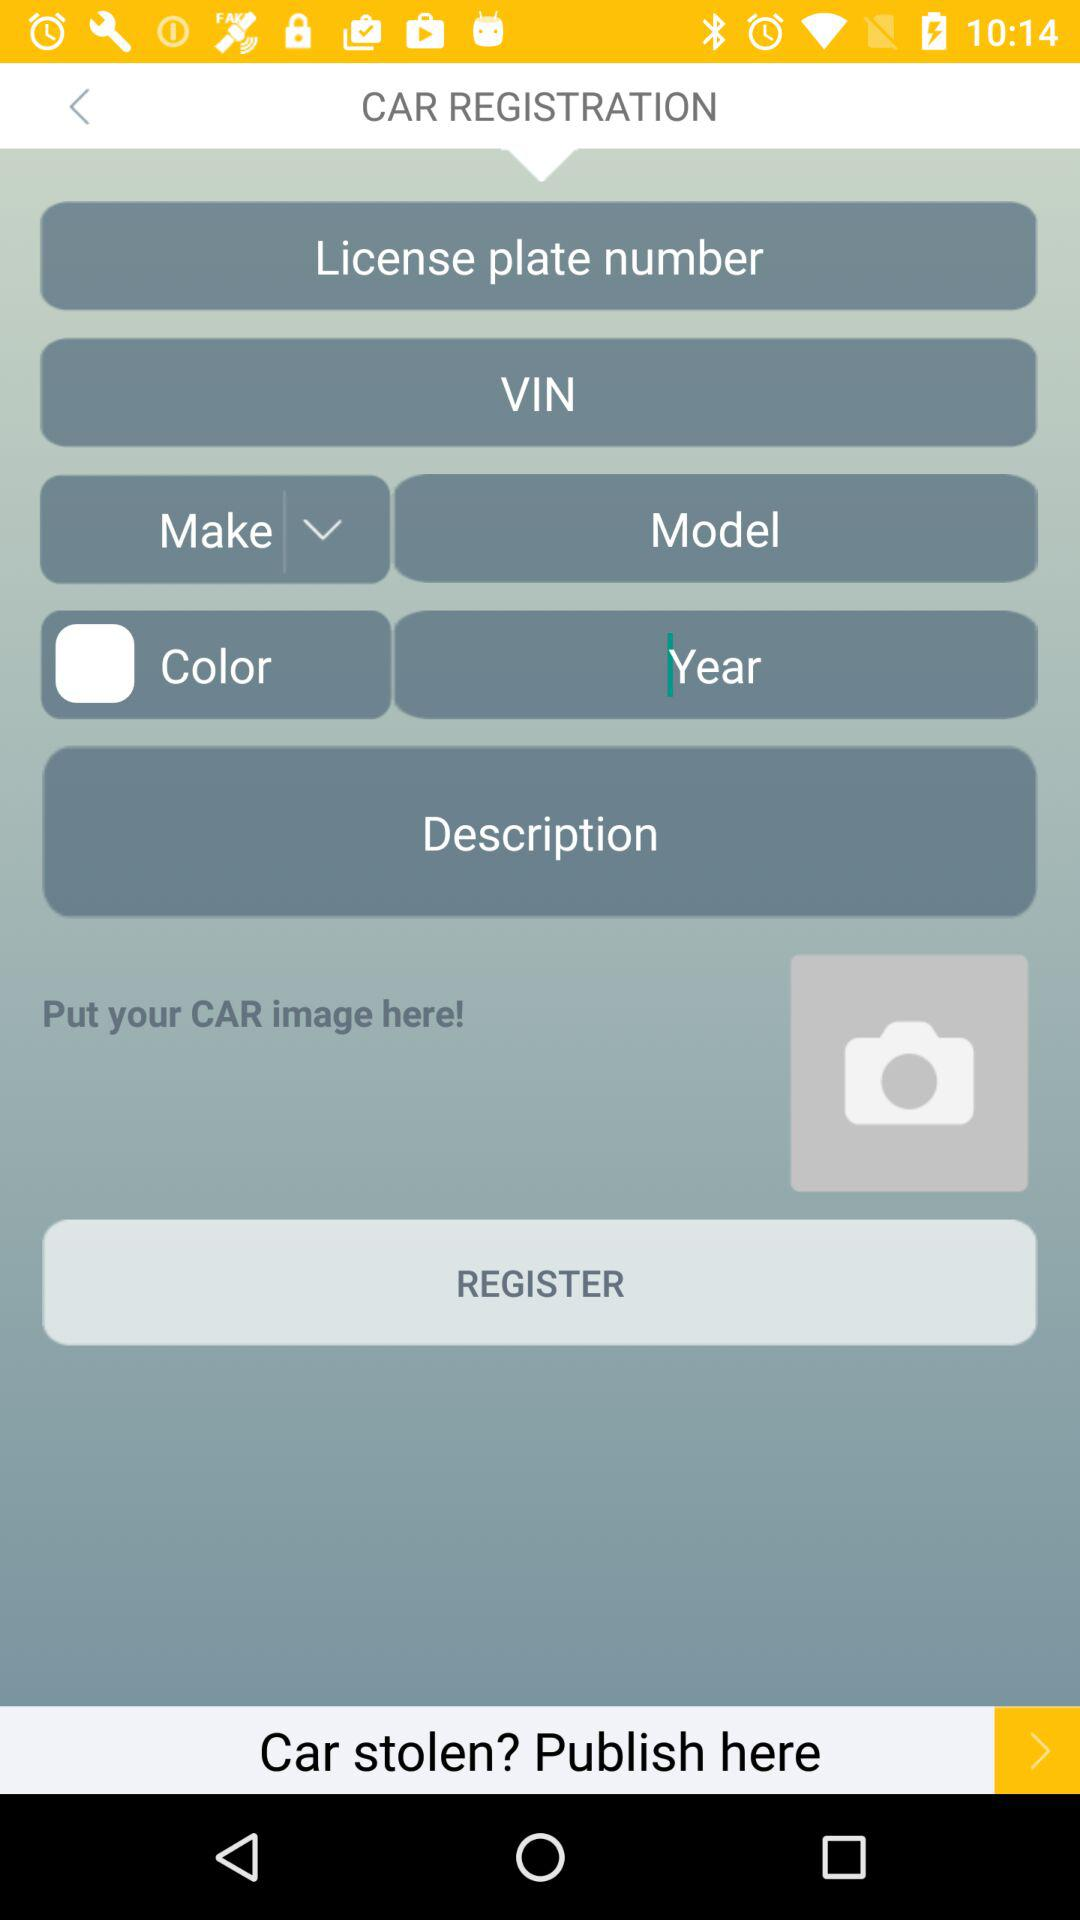How many input fields are there for the car's information?
Answer the question using a single word or phrase. 7 